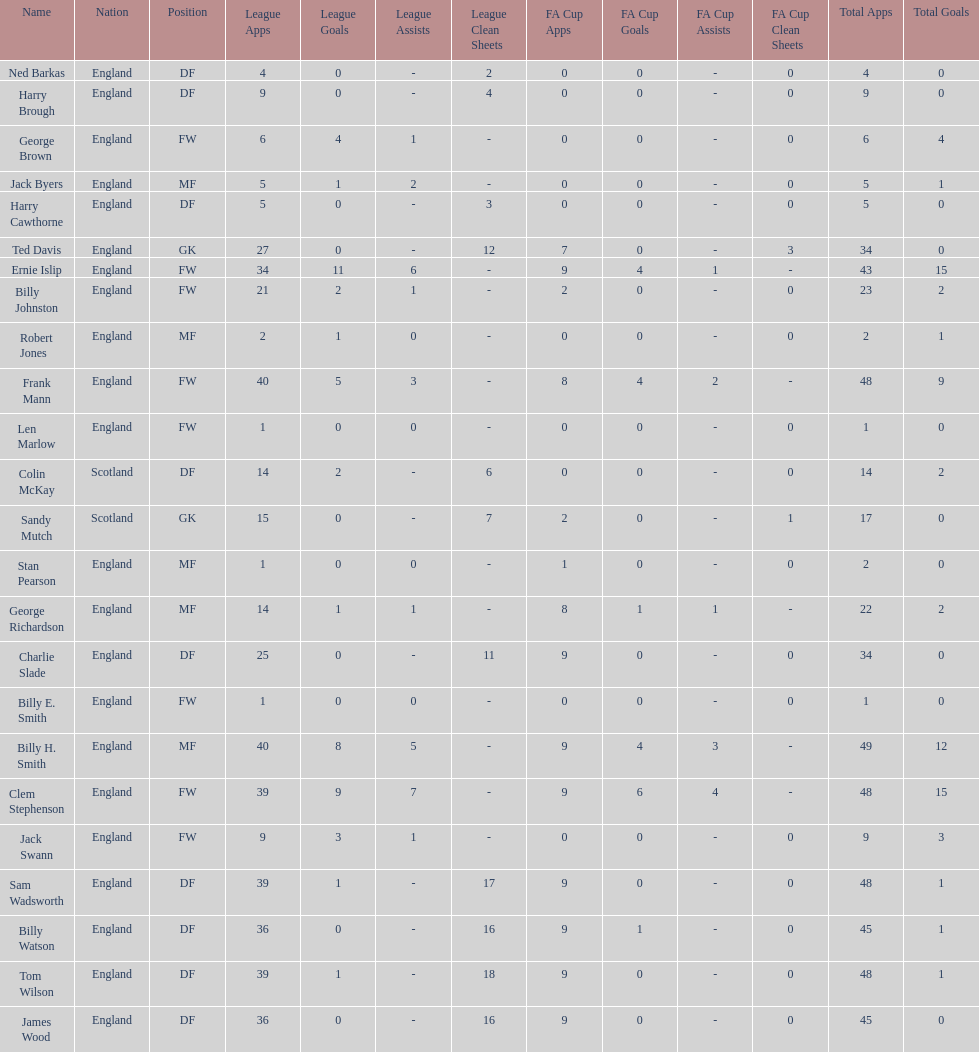How many players are fws? 8. Give me the full table as a dictionary. {'header': ['Name', 'Nation', 'Position', 'League Apps', 'League Goals', 'League Assists', 'League Clean Sheets', 'FA Cup Apps', 'FA Cup Goals', 'FA Cup Assists', 'FA Cup Clean Sheets', 'Total Apps', 'Total Goals'], 'rows': [['Ned Barkas', 'England', 'DF', '4', '0', '-', '2', '0', '0', '-', '0', '4', '0'], ['Harry Brough', 'England', 'DF', '9', '0', '-', '4', '0', '0', '-', '0', '9', '0'], ['George Brown', 'England', 'FW', '6', '4', '1', '-', '0', '0', '-', '0', '6', '4'], ['Jack Byers', 'England', 'MF', '5', '1', '2', '-', '0', '0', '-', '0', '5', '1'], ['Harry Cawthorne', 'England', 'DF', '5', '0', '-', '3', '0', '0', '-', '0', '5', '0'], ['Ted Davis', 'England', 'GK', '27', '0', '-', '12', '7', '0', '-', '3', '34', '0'], ['Ernie Islip', 'England', 'FW', '34', '11', '6', '-', '9', '4', '1', '-', '43', '15'], ['Billy Johnston', 'England', 'FW', '21', '2', '1', '-', '2', '0', '-', '0', '23', '2'], ['Robert Jones', 'England', 'MF', '2', '1', '0', '-', '0', '0', '-', '0', '2', '1'], ['Frank Mann', 'England', 'FW', '40', '5', '3', '-', '8', '4', '2', '-', '48', '9'], ['Len Marlow', 'England', 'FW', '1', '0', '0', '-', '0', '0', '-', '0', '1', '0'], ['Colin McKay', 'Scotland', 'DF', '14', '2', '-', '6', '0', '0', '-', '0', '14', '2'], ['Sandy Mutch', 'Scotland', 'GK', '15', '0', '-', '7', '2', '0', '-', '1', '17', '0'], ['Stan Pearson', 'England', 'MF', '1', '0', '0', '-', '1', '0', '-', '0', '2', '0'], ['George Richardson', 'England', 'MF', '14', '1', '1', '-', '8', '1', '1', '-', '22', '2'], ['Charlie Slade', 'England', 'DF', '25', '0', '-', '11', '9', '0', '-', '0', '34', '0'], ['Billy E. Smith', 'England', 'FW', '1', '0', '0', '-', '0', '0', '-', '0', '1', '0'], ['Billy H. Smith', 'England', 'MF', '40', '8', '5', '-', '9', '4', '3', '-', '49', '12'], ['Clem Stephenson', 'England', 'FW', '39', '9', '7', '-', '9', '6', '4', '-', '48', '15'], ['Jack Swann', 'England', 'FW', '9', '3', '1', '-', '0', '0', '-', '0', '9', '3'], ['Sam Wadsworth', 'England', 'DF', '39', '1', '-', '17', '9', '0', '-', '0', '48', '1'], ['Billy Watson', 'England', 'DF', '36', '0', '-', '16', '9', '1', '-', '0', '45', '1'], ['Tom Wilson', 'England', 'DF', '39', '1', '-', '18', '9', '0', '-', '0', '48', '1'], ['James Wood', 'England', 'DF', '36', '0', '-', '16', '9', '0', '-', '0', '45', '0']]} 